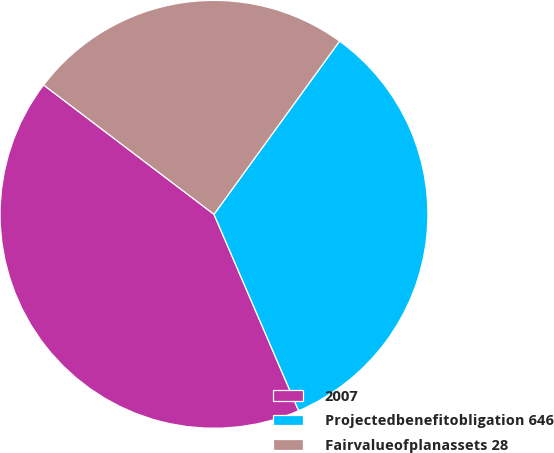Convert chart. <chart><loc_0><loc_0><loc_500><loc_500><pie_chart><fcel>2007<fcel>Projectedbenefitobligation 646<fcel>Fairvalueofplanassets 28<nl><fcel>41.81%<fcel>33.54%<fcel>24.65%<nl></chart> 